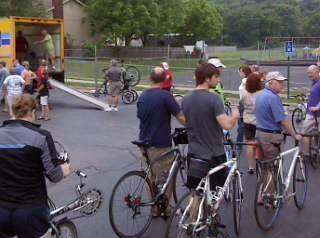How many people have hats?
Give a very brief answer. 2. How many people are in the picture?
Give a very brief answer. 4. How many bicycles are visible?
Give a very brief answer. 3. How many black dogs are there?
Give a very brief answer. 0. 